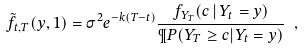<formula> <loc_0><loc_0><loc_500><loc_500>\tilde { f } _ { t , T } ( y , 1 ) = \sigma ^ { 2 } e ^ { - k ( T - t ) } \frac { f _ { Y _ { T } } ( c \, | \, Y _ { t } = y ) } { \P P ( Y _ { T } \geq c | Y _ { t } = y ) } \ ,</formula> 